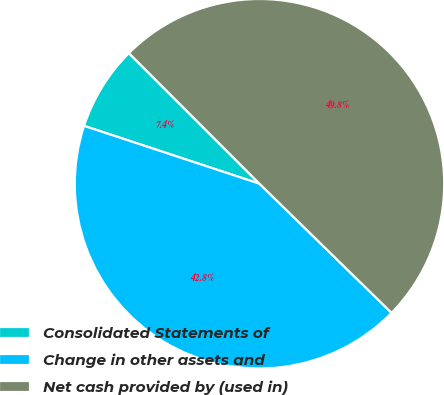Convert chart. <chart><loc_0><loc_0><loc_500><loc_500><pie_chart><fcel>Consolidated Statements of<fcel>Change in other assets and<fcel>Net cash provided by (used in)<nl><fcel>7.43%<fcel>42.75%<fcel>49.82%<nl></chart> 